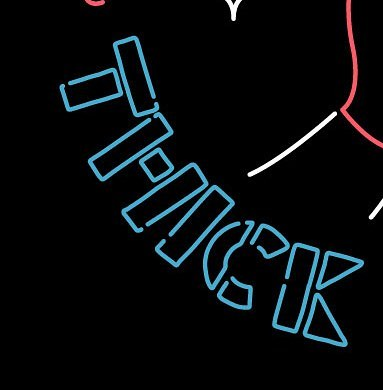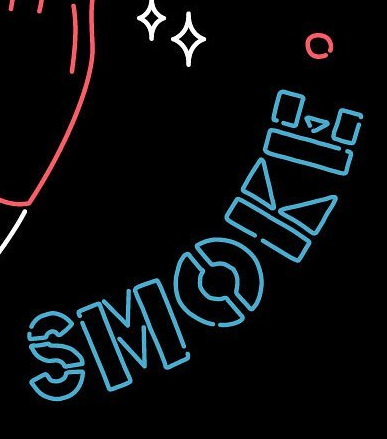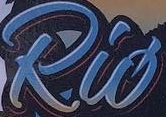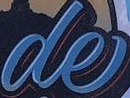What text is displayed in these images sequentially, separated by a semicolon? THICK; SMOKE; Rió; de 